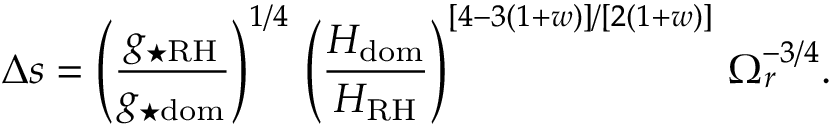Convert formula to latex. <formula><loc_0><loc_0><loc_500><loc_500>\Delta s = \left ( \frac { g _ { ^ { * } R H } } { g _ { ^ { * } d o m } } \right ) ^ { 1 / 4 } \, \left ( \frac { H _ { d o m } } { H _ { R H } } \right ) ^ { [ 4 - 3 ( 1 + w ) ] / [ 2 ( 1 + w ) ] } \, \Omega _ { r } ^ { - 3 / 4 } .</formula> 